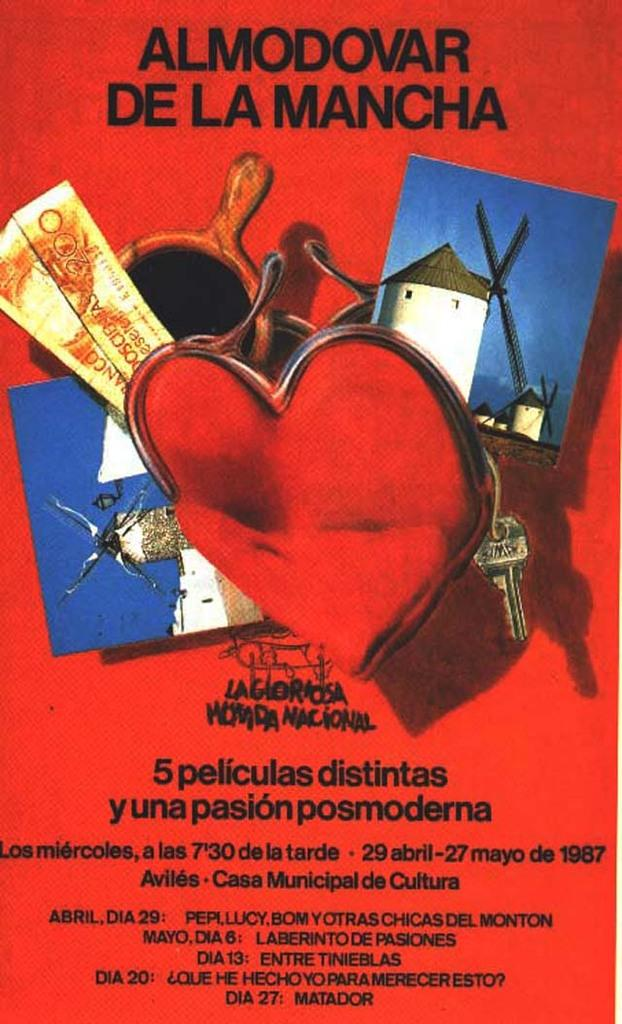Provide a one-sentence caption for the provided image. A poster says Almodovar De La Manchar, 5 peliculas distintas y una pasion posmoderna. 